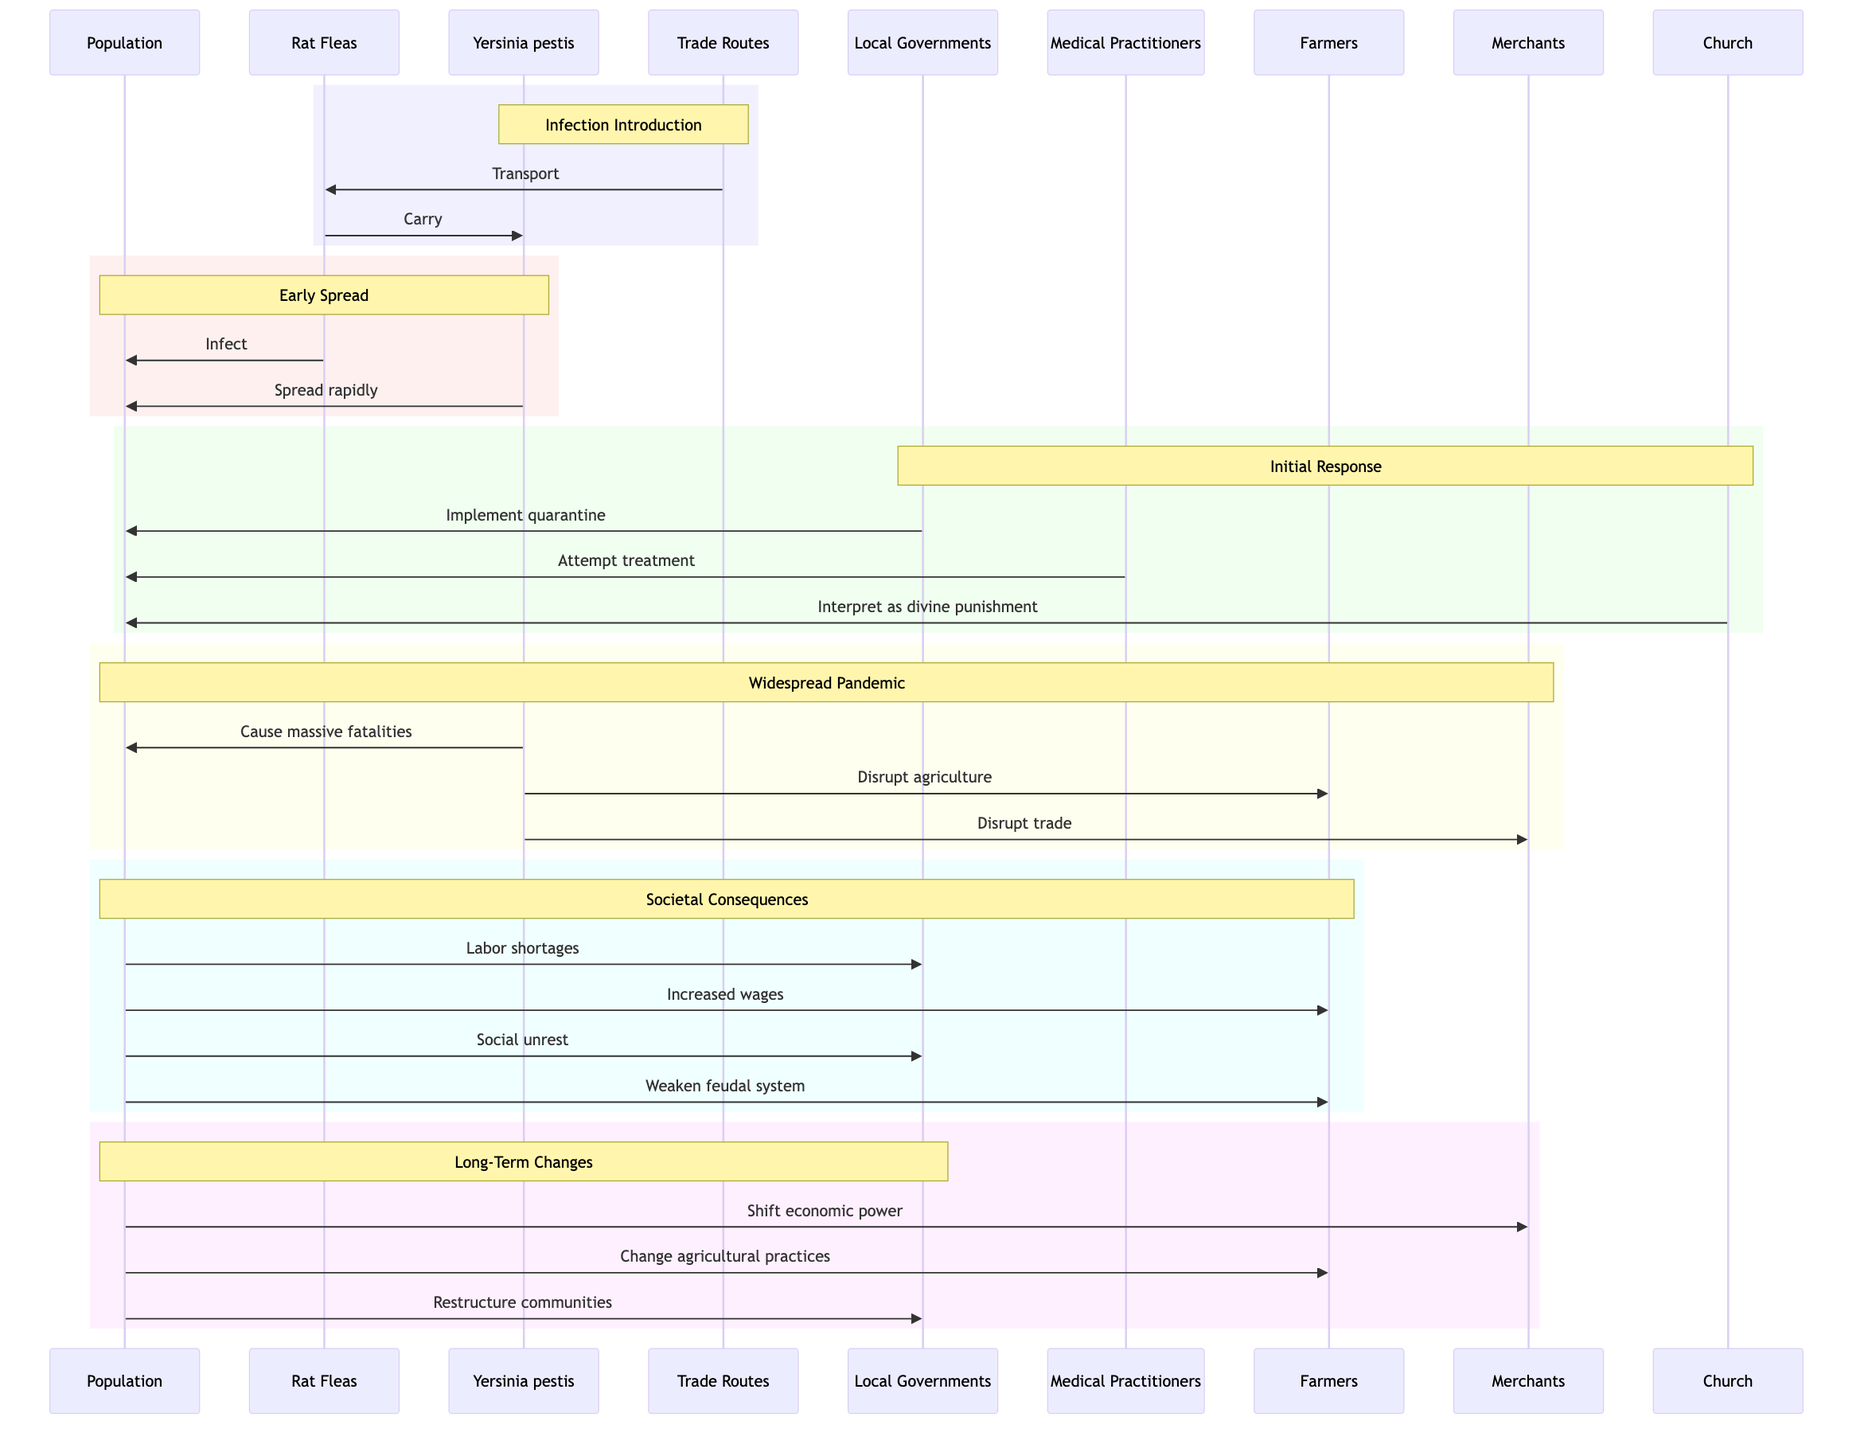What are the three actors involved in the "Infection Introduction" event? The event "Infection Introduction" involves the actors Trade Routes, Rat Fleas, and Yersinia pestis Bacteria as indicated in the first rectangular section of the diagram.
Answer: Trade Routes, Rat Fleas, Yersinia pestis Bacteria Which actor implements quarantine measures during the "Initial Response"? The "Initial Response" section specifies that Local Governments implement quarantine measures as an attempt to contain the spread of the disease.
Answer: Local Governments How many total events are depicted in the diagram? Counting the distinct events in the diagram, there are six events: Infection Introduction, Early Spread, Initial Response, Widespread Pandemic, Societal Consequences, and Long-Term Changes.
Answer: Six What is the consequence of the "Widespread Pandemic" on agriculture? The "Widespread Pandemic" section notes that Yersinia pestis disrupts agriculture, leading to significant impact on farmers and food production.
Answer: Disrupt agriculture Which actors are impacted by high mortality rates during the "Widespread Pandemic"? The "Widespread Pandemic" event affects the Population, Farmers, and Merchants, as all these groups are listed with interactions related to the impact of high mortality rates caused by Yersinia pestis.
Answer: Population, Farmers, Merchants What major societal change occurs due to labor shortages in the "Societal Consequences"? The labor shortages lead to increased wages and social unrest, indicating a shift in societal dynamics due to reduced workforce availability.
Answer: Increased wages Which actor experiences a shift in economic power as noted in the "Long-Term Changes"? The diagram specifies that the Population experiences a shift in economic power, which suggests that power dynamics and economic roles change following the pandemic's aftermath.
Answer: Population Why does the Church interpret the plague as divine punishment during the "Initial Response"? According to the "Initial Response," the Church perceives the plague as divine punishment because it was a common historical explanation for calamities, reflecting societal beliefs at that time.
Answer: Divine punishment 